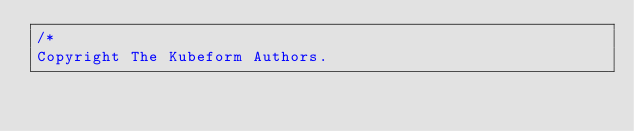<code> <loc_0><loc_0><loc_500><loc_500><_Go_>/*
Copyright The Kubeform Authors.
</code> 